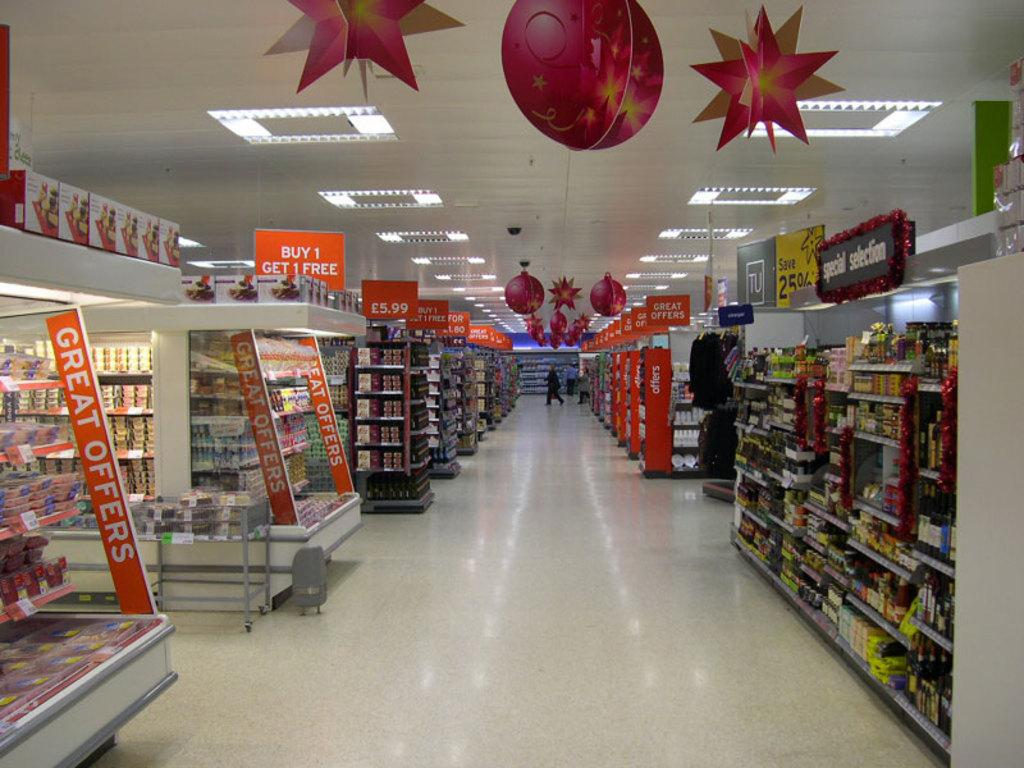Provide a one-sentence caption for the provided image. The grocery section of a store that has great offers advertised on the ends of several isles. 